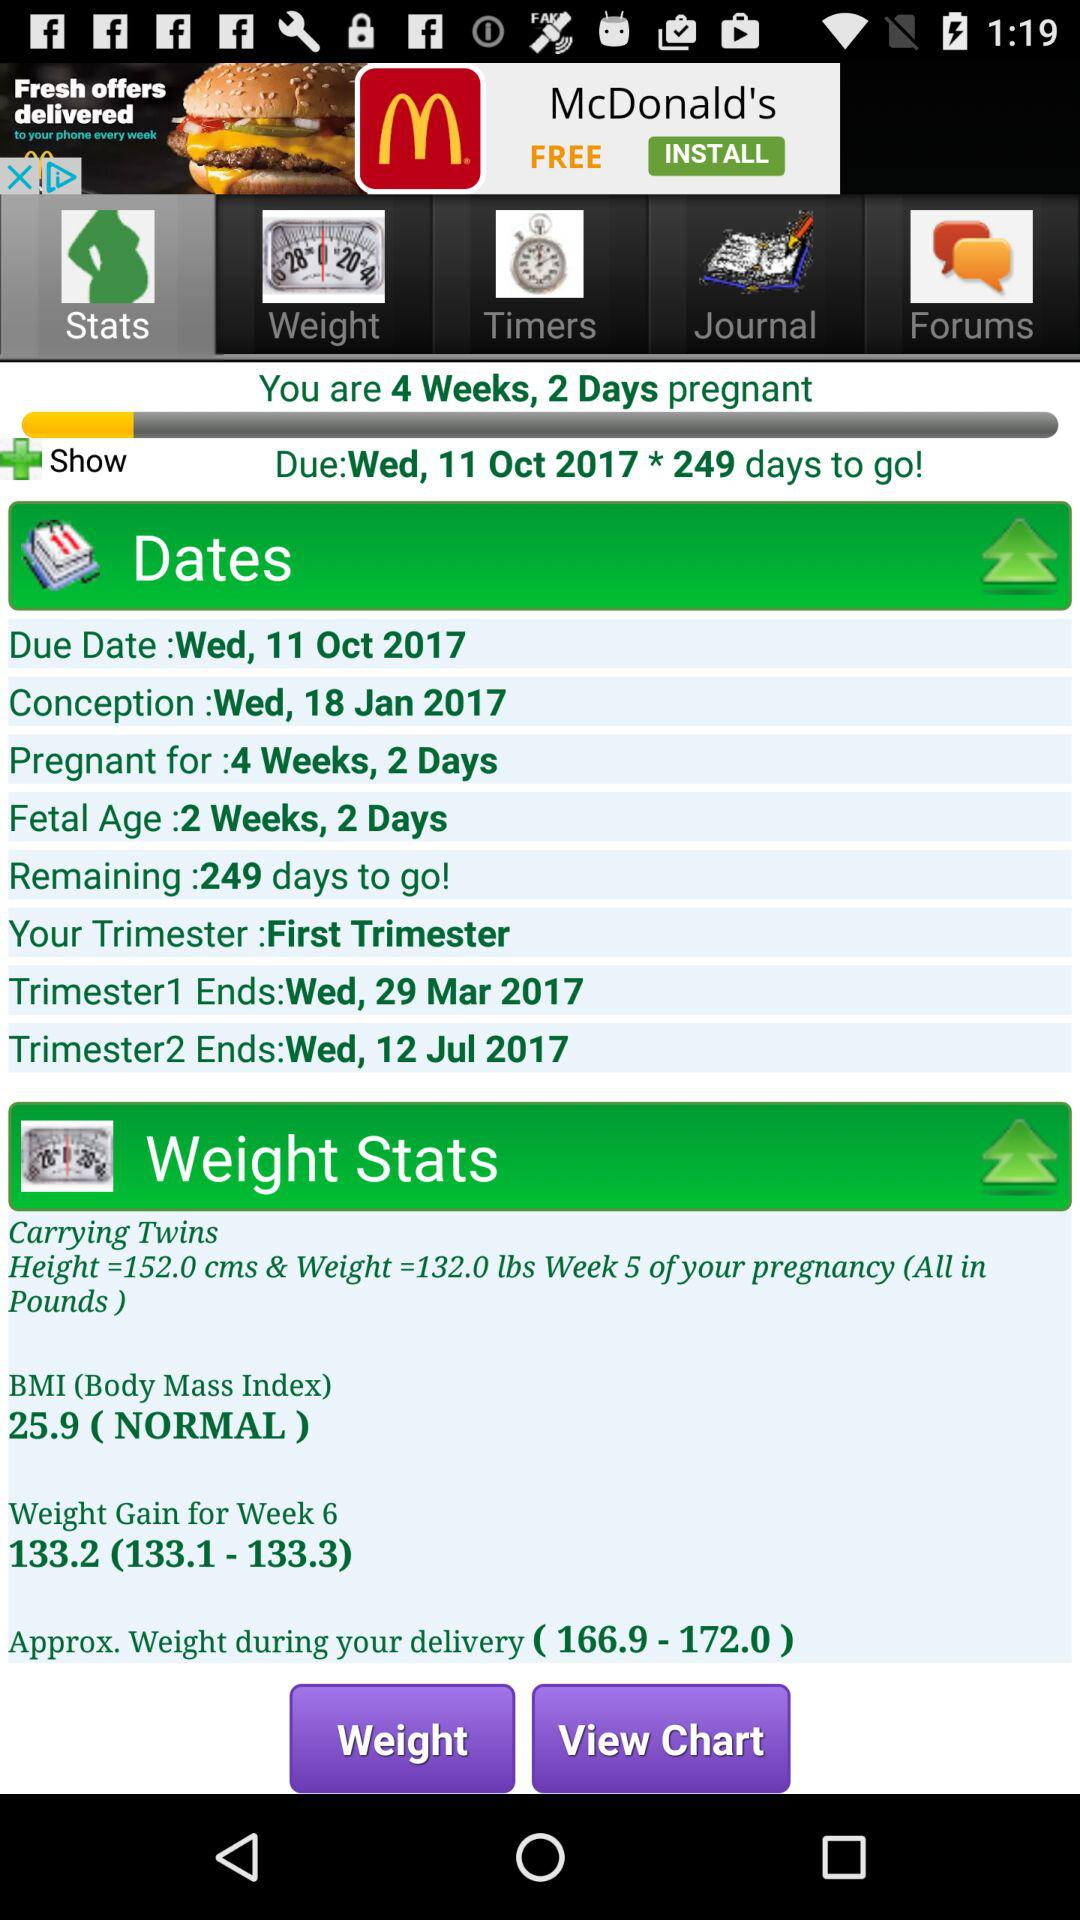How many days until the due date?
Answer the question using a single word or phrase. 249 